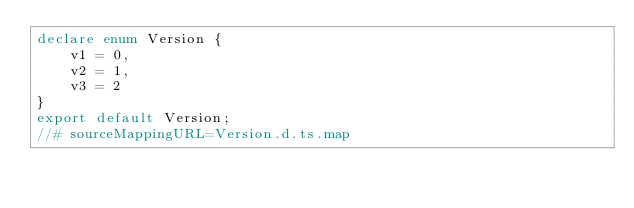<code> <loc_0><loc_0><loc_500><loc_500><_TypeScript_>declare enum Version {
    v1 = 0,
    v2 = 1,
    v3 = 2
}
export default Version;
//# sourceMappingURL=Version.d.ts.map</code> 